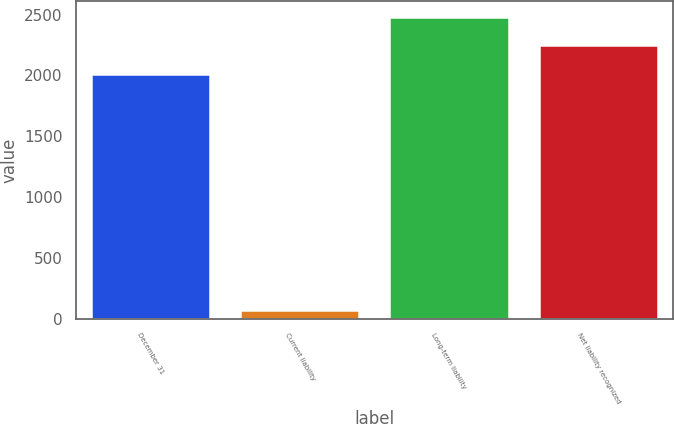<chart> <loc_0><loc_0><loc_500><loc_500><bar_chart><fcel>December 31<fcel>Current liability<fcel>Long-term liability<fcel>Net liability recognized<nl><fcel>2012<fcel>73<fcel>2483.6<fcel>2247.8<nl></chart> 